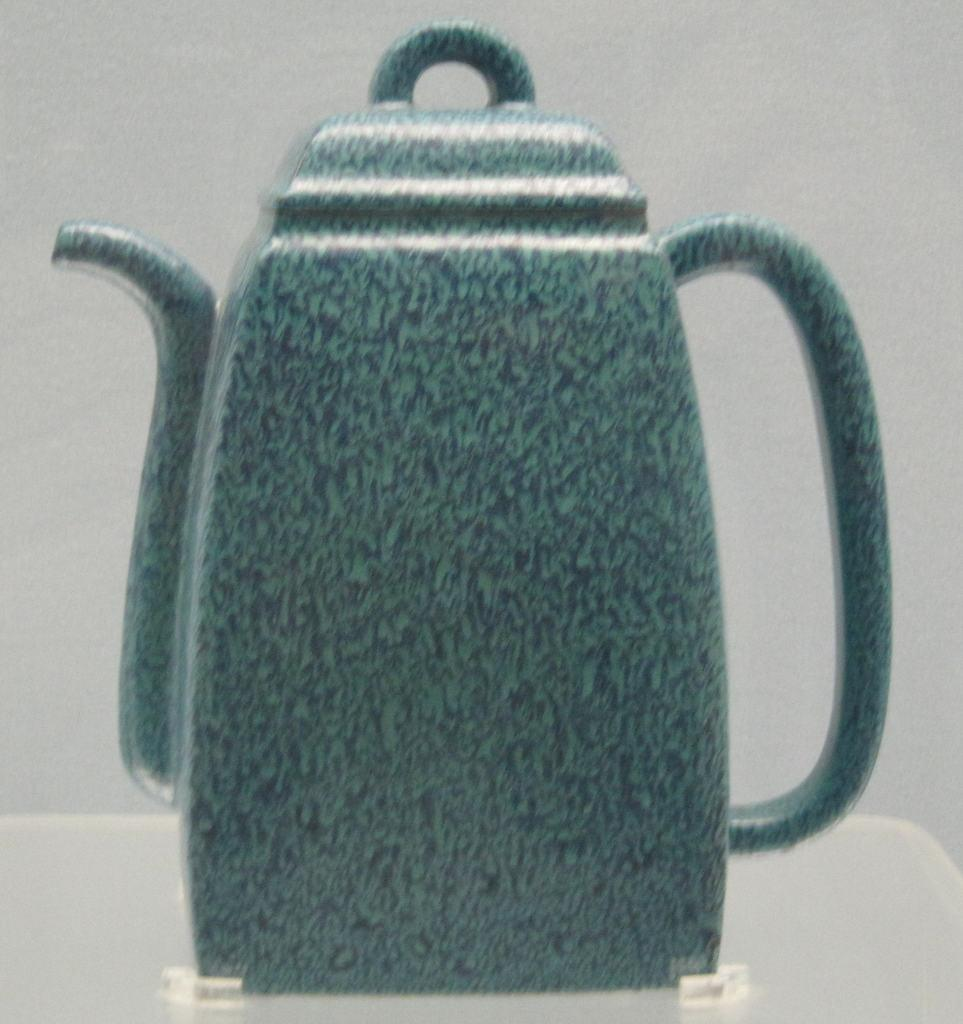What is the main object in the image? There is a tea kettle in the image. Where is the tea kettle located? The tea kettle is on a table. What is the purpose of the tea kettle running in the image? There is no tea kettle running in the image; it is stationary on the table. 